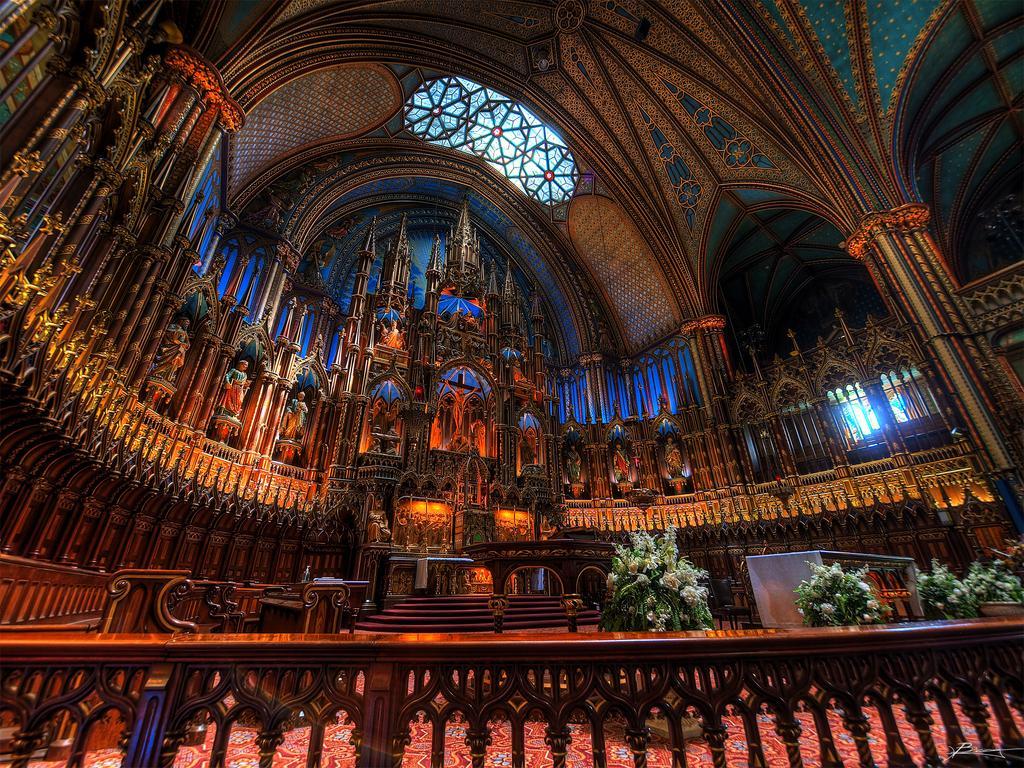Could you give a brief overview of what you see in this image? In this image we can see there are house plants, stairs and railing. And at the top there is the window. And there are sculptures and design to the wall. 